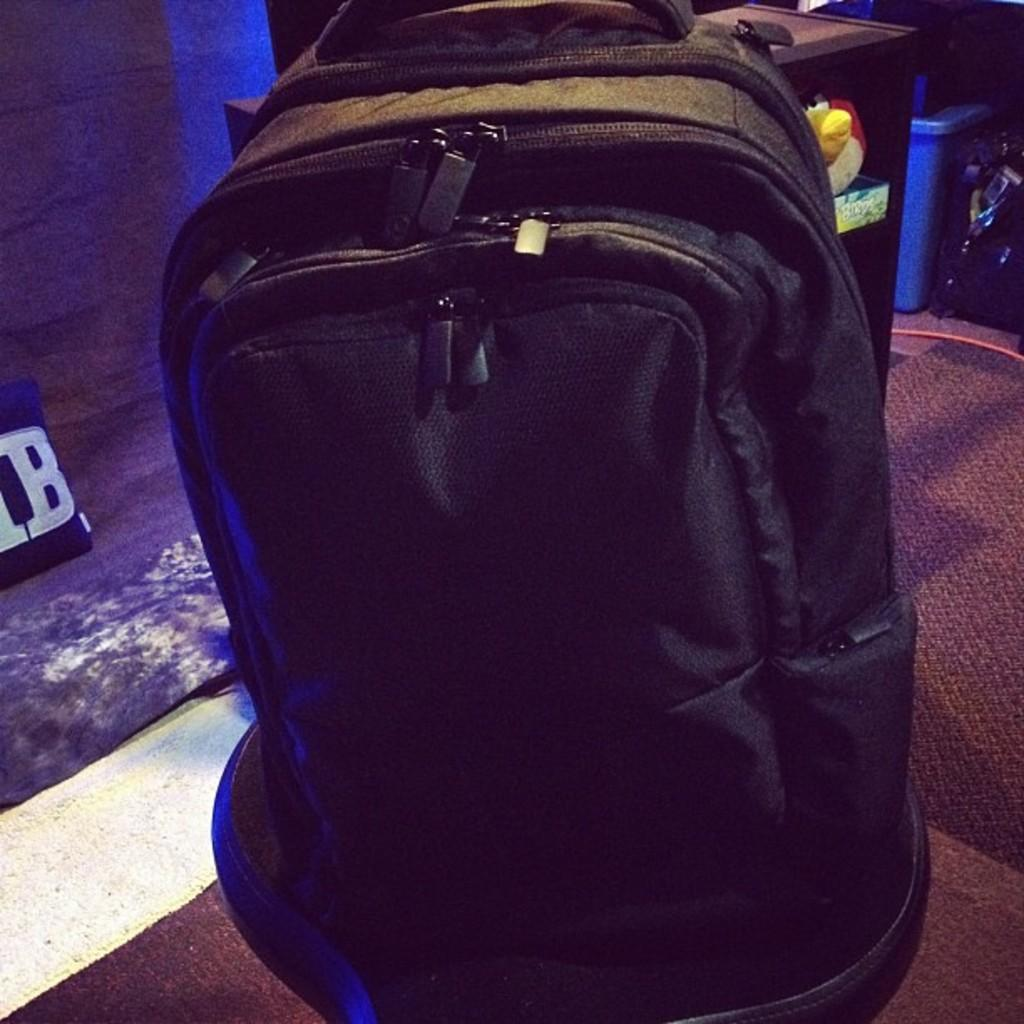What object is present on the floor in the image? There is a bag in the image. Where is the bag located on the floor? The bag is on a floor mat. What type of quill is being used in the argument depicted in the image? There is no argument or quill present in the image; it only features a bag on a floor mat. 